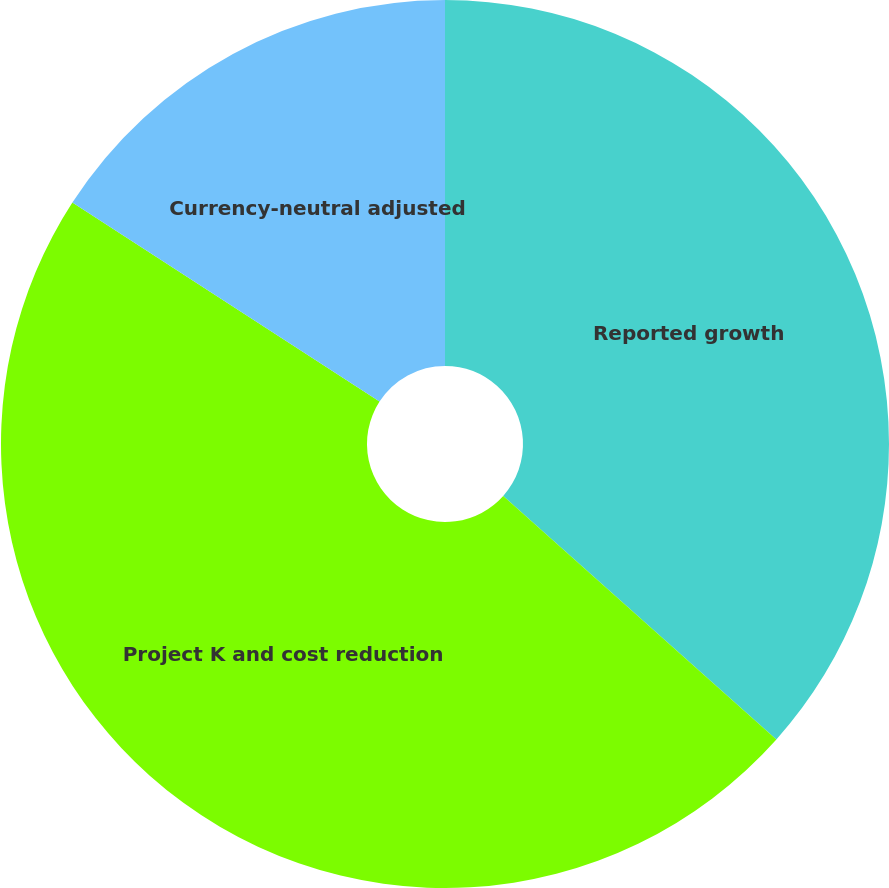<chart> <loc_0><loc_0><loc_500><loc_500><pie_chart><fcel>Reported growth<fcel>Project K and cost reduction<fcel>Currency-neutral adjusted<nl><fcel>36.59%<fcel>47.56%<fcel>15.85%<nl></chart> 